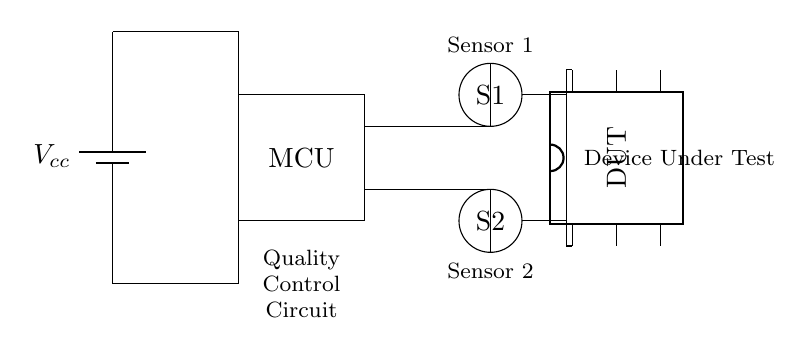What type of component is represented by 'DUT'? The 'DUT' component is a device under test, indicated as a dip chip with six pins, which is typically used for testing electronic functionality.
Answer: device under test How many sensors are in the circuit? There are two sensors in the circuit, labeled as S1 and S2, which are placed at positions indicating their function in the quality control process.
Answer: two What is the power source for the circuit? The circuit uses a battery as the power source, indicated by the label 'Vcc' at the top of the circuit diagram, supplying voltage to the components.
Answer: battery What is the function of the microcontroller in this circuit? The microcontroller (MCU) controls the operation of the circuit, processing inputs from the sensors and managing the testing procedure of the device under test.
Answer: control Which sensor is positioned higher in the diagram? Sensor 1 (S1) is positioned higher in the diagram compared to Sensor 2 (S2), as it is located in the upper part of the circuit layout.
Answer: Sensor 1 How do the sensors connect to the device under test? The sensors connect to the device under test through wires that lead from each sensor's output to the corresponding pins of the DUT, facilitating the testing process.
Answer: wires What is the orientation of the device under test? The device under test is oriented vertically, as indicated by the way it is drawn in the diagram and the label that identifies it.
Answer: vertical 